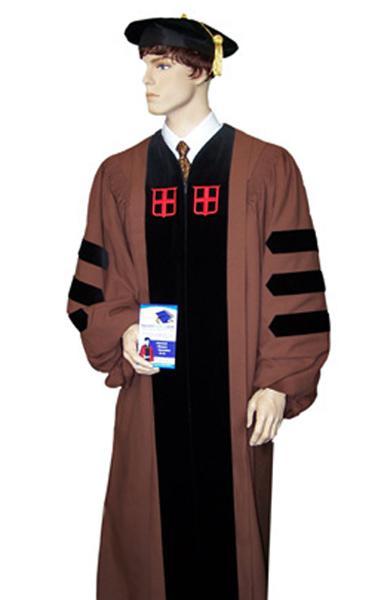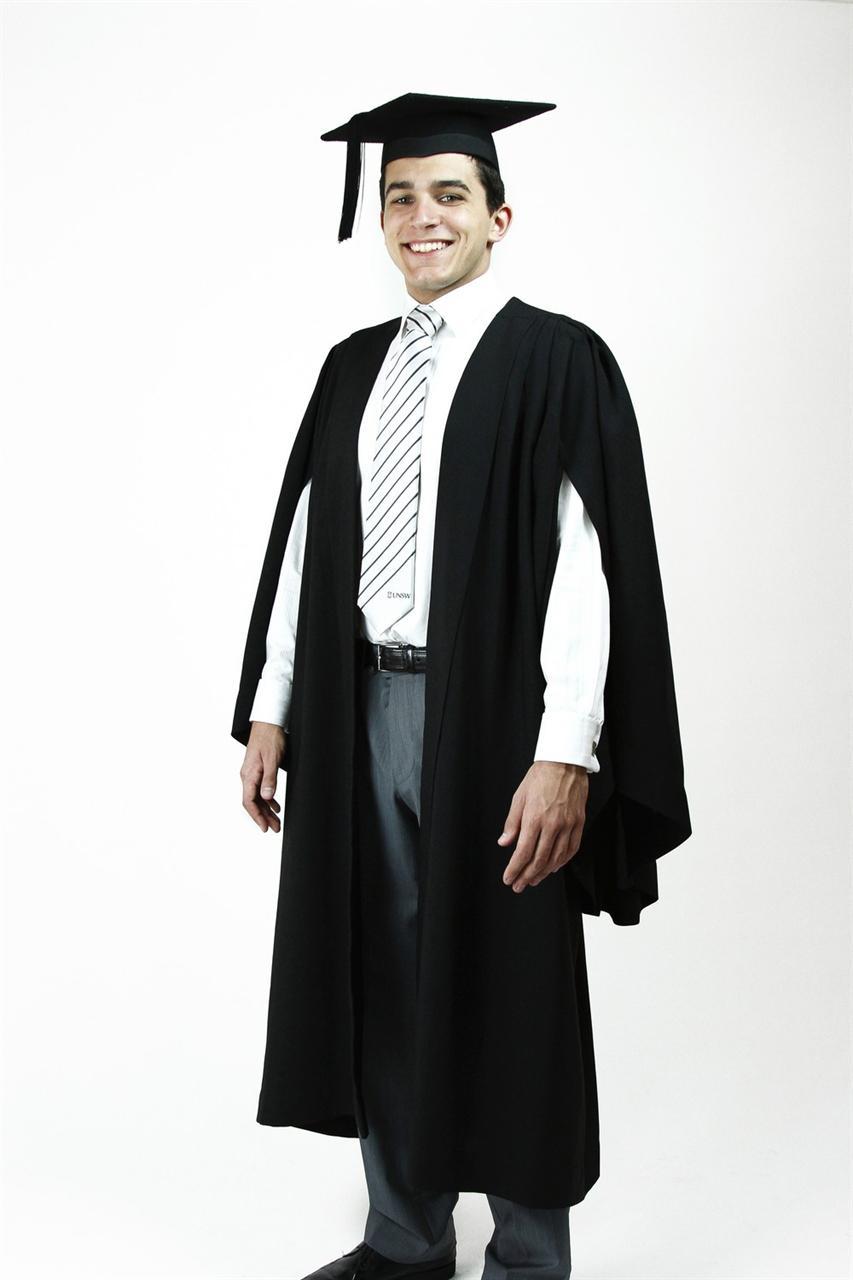The first image is the image on the left, the second image is the image on the right. Examine the images to the left and right. Is the description "White sleeves are almost completely exposed in one of the images." accurate? Answer yes or no. Yes. 